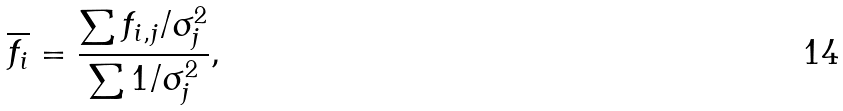<formula> <loc_0><loc_0><loc_500><loc_500>\overline { f _ { i } } = \frac { \sum f _ { i , j } / \sigma _ { j } ^ { 2 } } { \sum 1 / \sigma _ { j } ^ { 2 } } ,</formula> 